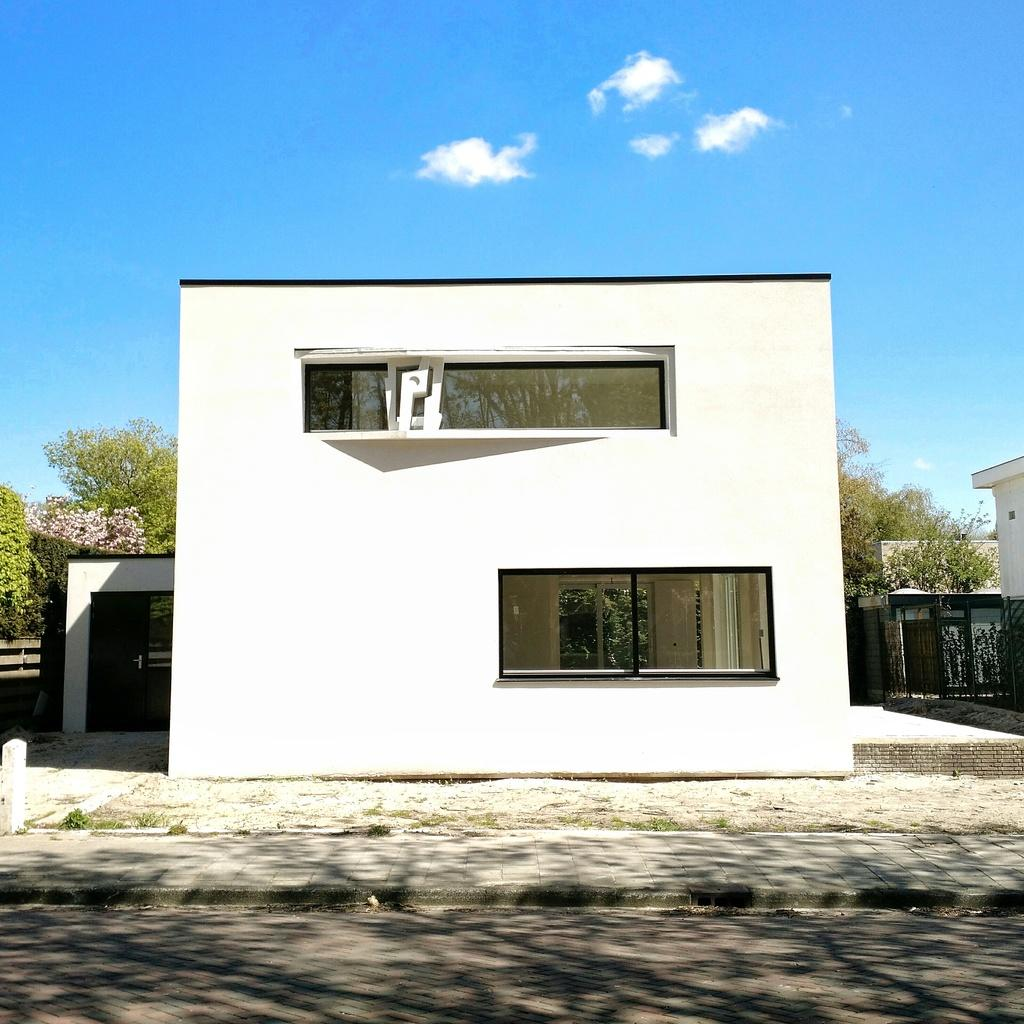What type of structures can be seen in the image? There are buildings in the image. What type of vegetation is present in the image? There are trees and flowers in the image. What can be seen in the sky in the image? There are clouds in the image. What type of rod can be seen in the image? There is no rod present in the image. What effect does the fog have on the visibility of the buildings in the image? There is no fog present in the image, so its effect on visibility cannot be determined. 